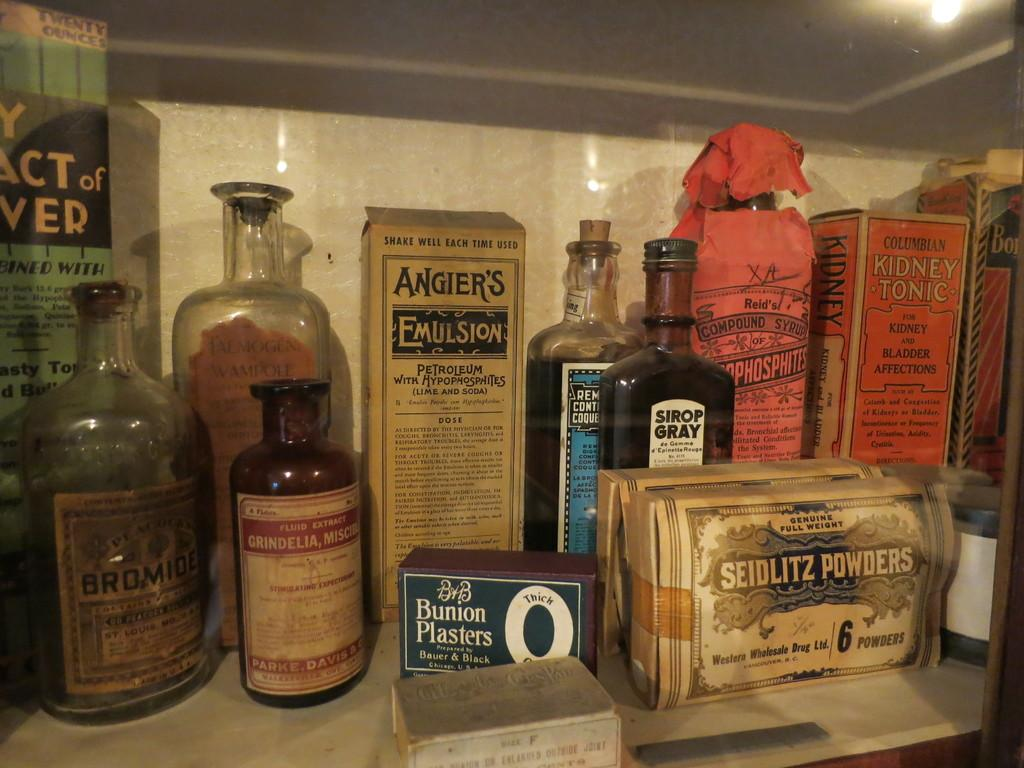<image>
Relay a brief, clear account of the picture shown. A collection of very old items including a box of Bunion plasters. 